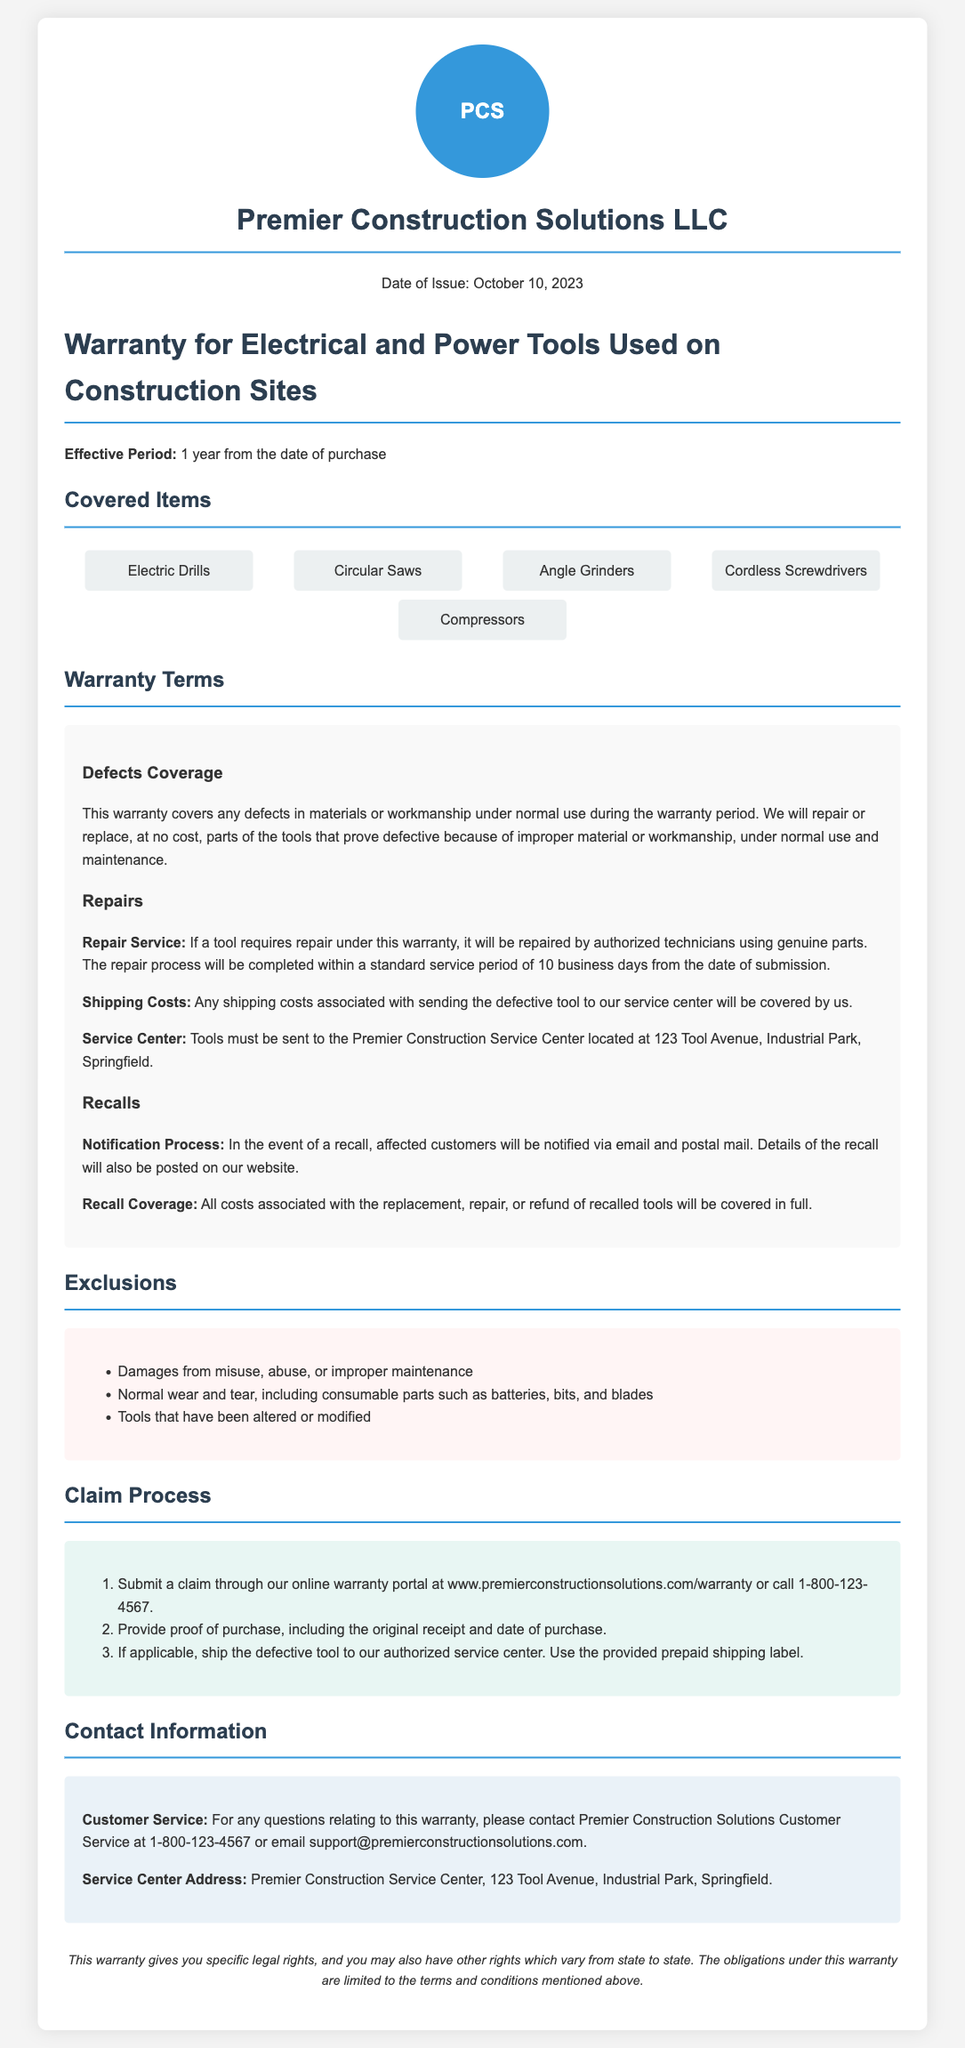What is the effective period of the warranty? The effective period of the warranty is mentioned in the document, which states it is valid for a duration of 1 year from the date of purchase.
Answer: 1 year What address must defective tools be sent to? The document specifies the location of the service center for repairs, which is important for understanding where to send defective tools.
Answer: 123 Tool Avenue, Industrial Park, Springfield What types of tools are covered under this warranty? The document outlines several specific tools that are covered, making this a clear retrieval question focusing on a list of items.
Answer: Electric Drills, Circular Saws, Angle Grinders, Cordless Screwdrivers, Compressors How long will repairs take? The repair service section states a specific time frame for the repair process of defective tools, which needs to be extracted.
Answer: 10 business days What costs are covered under recall coverage? The document details what recalls entail and the coverage included, making this a specific type of question regarding recall provisions.
Answer: All costs associated with the replacement, repair, or refund What exclusions are outlined in the warranty? The document lists several items that are excluded from the warranty, which is critical for understanding its limitations.
Answer: Damages from misuse, abuse, or improper maintenance How can a claim be submitted? The claim process describes the steps necessary to submit a warranty claim, making it a relevant document-specific inquiry.
Answer: Through our online warranty portal or call 1-800-123-4567 What is the date of issue for the warranty document? Inputting a specific date mentioned in the company info section will yield a direct retrieval of the issued date.
Answer: October 10, 2023 